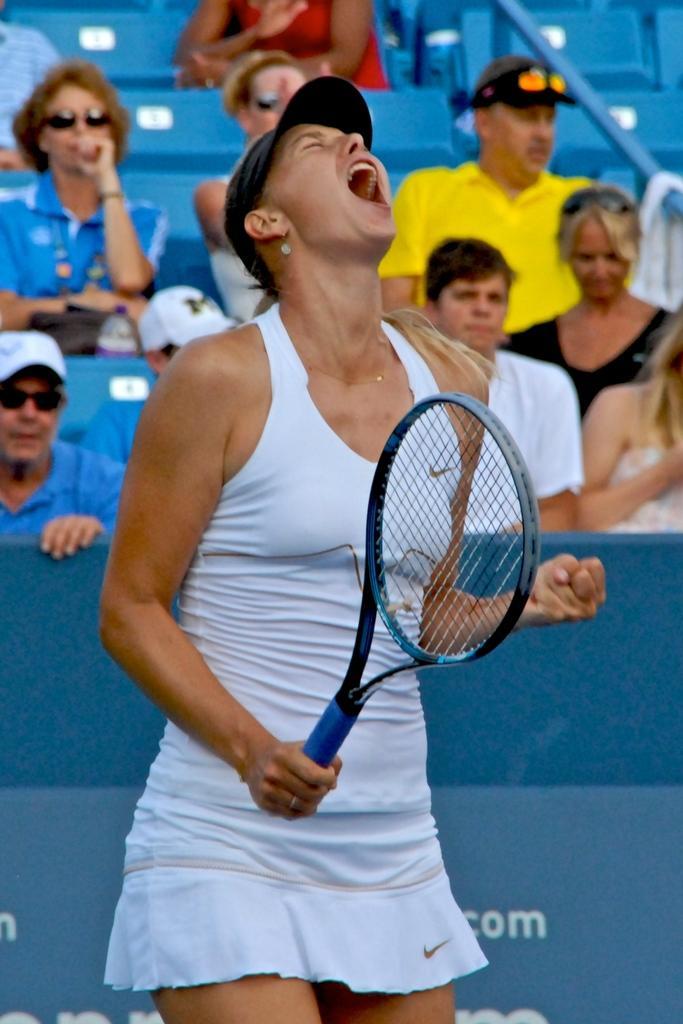In one or two sentences, can you explain what this image depicts? In the image we can see there is a woman who is holding a tennis racket and behind her there are lot of people sitting. 